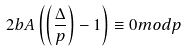Convert formula to latex. <formula><loc_0><loc_0><loc_500><loc_500>2 b A \left ( \left ( \frac { \Delta } { p } \right ) - 1 \right ) \equiv 0 m o d p</formula> 